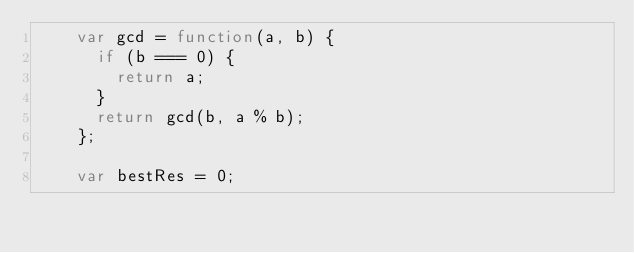<code> <loc_0><loc_0><loc_500><loc_500><_JavaScript_>    var gcd = function(a, b) {
      if (b === 0) {
        return a;
      }
      return gcd(b, a % b);
    };
  
    var bestRes = 0;
  </code> 